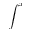<formula> <loc_0><loc_0><loc_500><loc_500>\int ^ { x }</formula> 